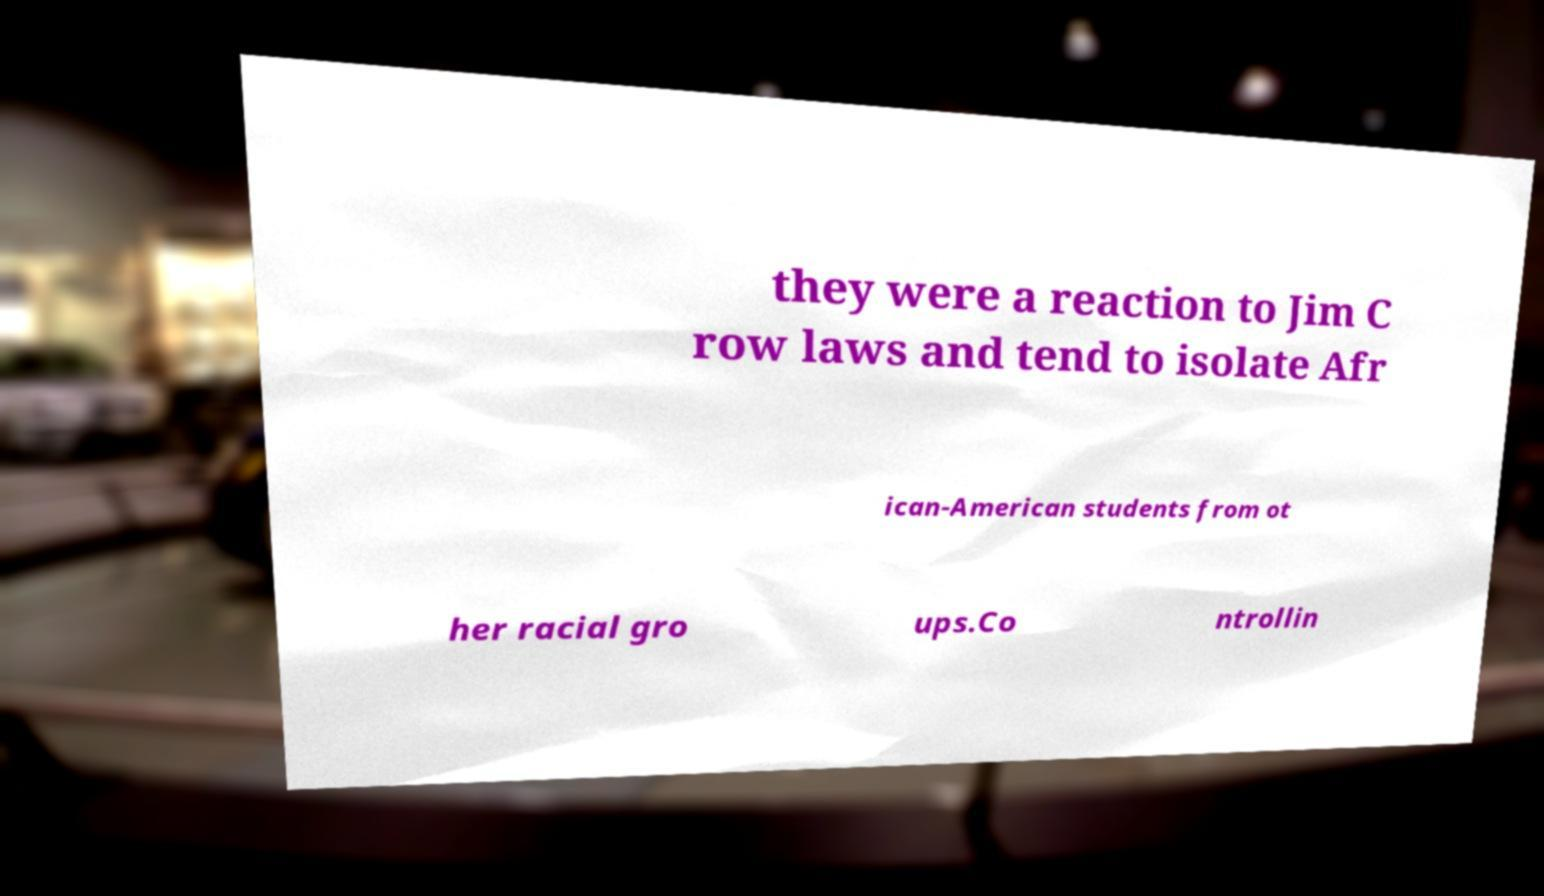Could you extract and type out the text from this image? they were a reaction to Jim C row laws and tend to isolate Afr ican-American students from ot her racial gro ups.Co ntrollin 